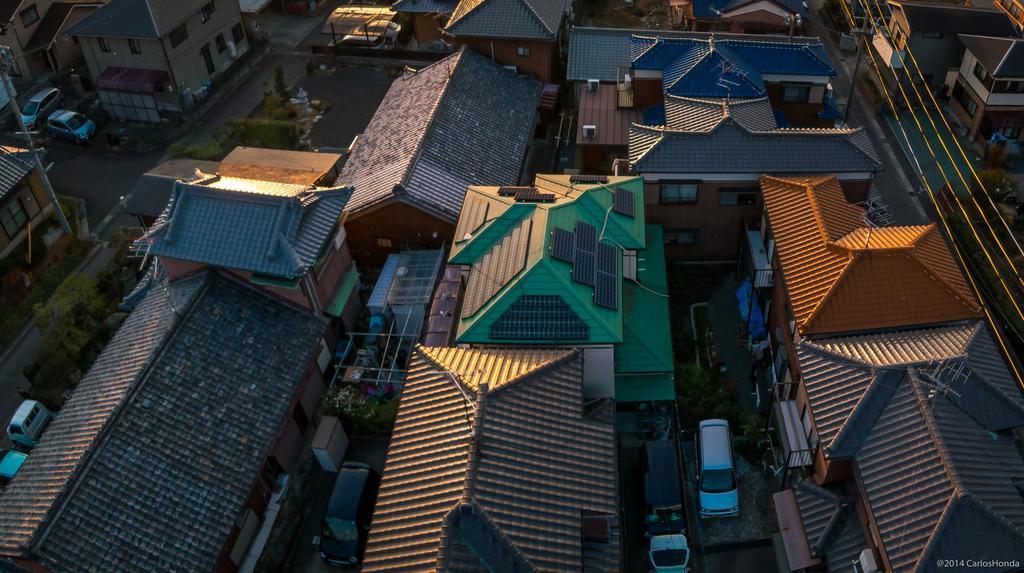Please provide a concise description of this image. In this picture I can see there are few buildings and there are plants and trees and there are vehicles parked at the buildings and there are few electric cables on to right side of the image. 